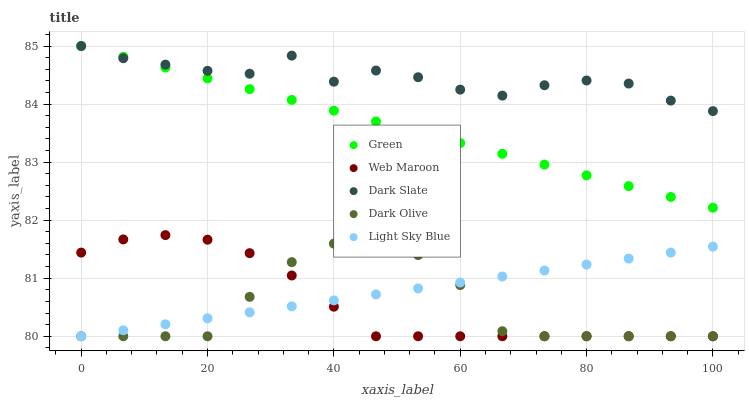Does Dark Olive have the minimum area under the curve?
Answer yes or no. Yes. Does Dark Slate have the maximum area under the curve?
Answer yes or no. Yes. Does Green have the minimum area under the curve?
Answer yes or no. No. Does Green have the maximum area under the curve?
Answer yes or no. No. Is Green the smoothest?
Answer yes or no. Yes. Is Dark Slate the roughest?
Answer yes or no. Yes. Is Dark Olive the smoothest?
Answer yes or no. No. Is Dark Olive the roughest?
Answer yes or no. No. Does Web Maroon have the lowest value?
Answer yes or no. Yes. Does Green have the lowest value?
Answer yes or no. No. Does Dark Slate have the highest value?
Answer yes or no. Yes. Does Dark Olive have the highest value?
Answer yes or no. No. Is Dark Olive less than Dark Slate?
Answer yes or no. Yes. Is Dark Slate greater than Web Maroon?
Answer yes or no. Yes. Does Green intersect Dark Slate?
Answer yes or no. Yes. Is Green less than Dark Slate?
Answer yes or no. No. Is Green greater than Dark Slate?
Answer yes or no. No. Does Dark Olive intersect Dark Slate?
Answer yes or no. No. 